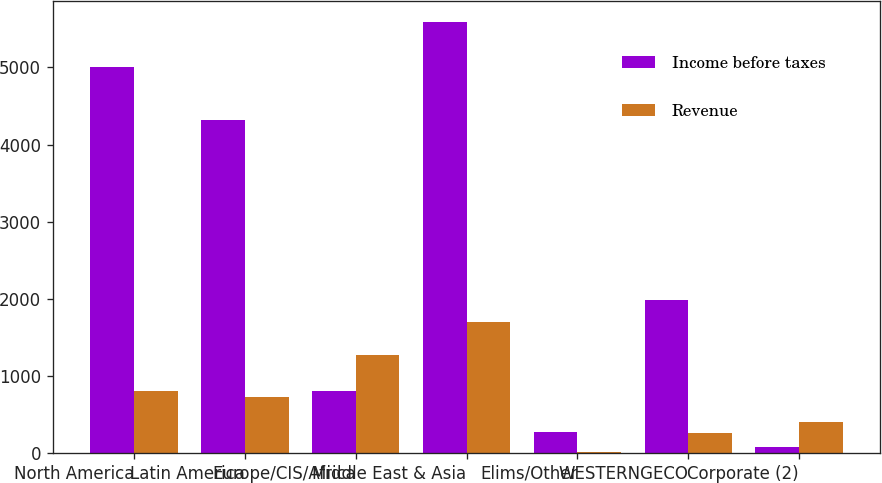Convert chart. <chart><loc_0><loc_0><loc_500><loc_500><stacked_bar_chart><ecel><fcel>North America<fcel>Latin America<fcel>Europe/CIS/Africa<fcel>Middle East & Asia<fcel>Elims/Other<fcel>WESTERNGECO<fcel>Corporate (2)<nl><fcel>Income before taxes<fcel>5010<fcel>4321<fcel>802<fcel>5586<fcel>280<fcel>1987<fcel>82<nl><fcel>Revenue<fcel>802<fcel>723<fcel>1269<fcel>1696<fcel>15<fcel>267<fcel>405<nl></chart> 